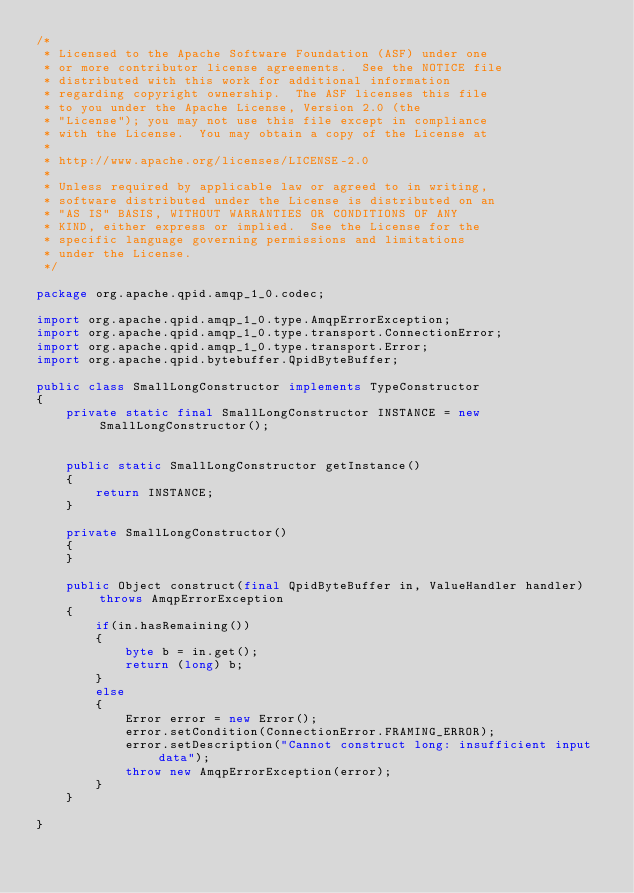<code> <loc_0><loc_0><loc_500><loc_500><_Java_>/*
 * Licensed to the Apache Software Foundation (ASF) under one
 * or more contributor license agreements.  See the NOTICE file
 * distributed with this work for additional information
 * regarding copyright ownership.  The ASF licenses this file
 * to you under the Apache License, Version 2.0 (the
 * "License"); you may not use this file except in compliance
 * with the License.  You may obtain a copy of the License at
 *
 * http://www.apache.org/licenses/LICENSE-2.0
 *
 * Unless required by applicable law or agreed to in writing,
 * software distributed under the License is distributed on an
 * "AS IS" BASIS, WITHOUT WARRANTIES OR CONDITIONS OF ANY
 * KIND, either express or implied.  See the License for the
 * specific language governing permissions and limitations
 * under the License.
 */

package org.apache.qpid.amqp_1_0.codec;

import org.apache.qpid.amqp_1_0.type.AmqpErrorException;
import org.apache.qpid.amqp_1_0.type.transport.ConnectionError;
import org.apache.qpid.amqp_1_0.type.transport.Error;
import org.apache.qpid.bytebuffer.QpidByteBuffer;

public class SmallLongConstructor implements TypeConstructor
{
    private static final SmallLongConstructor INSTANCE = new SmallLongConstructor();


    public static SmallLongConstructor getInstance()
    {
        return INSTANCE;
    }

    private SmallLongConstructor()
    {
    }

    public Object construct(final QpidByteBuffer in, ValueHandler handler) throws AmqpErrorException
    {
        if(in.hasRemaining())
        {
            byte b = in.get();
            return (long) b;
        }
        else
        {
            Error error = new Error();
            error.setCondition(ConnectionError.FRAMING_ERROR);
            error.setDescription("Cannot construct long: insufficient input data");
            throw new AmqpErrorException(error);
        }
    }

}
</code> 